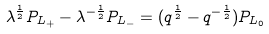<formula> <loc_0><loc_0><loc_500><loc_500>\lambda ^ { \frac { 1 } { 2 } } P _ { L _ { + } } - \lambda ^ { - \frac { 1 } { 2 } } P _ { L _ { - } } = ( q ^ { \frac { 1 } { 2 } } - q ^ { - \frac { 1 } { 2 } } ) P _ { L _ { 0 } }</formula> 